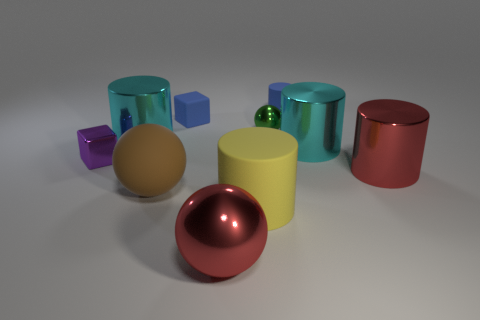Subtract all tiny spheres. How many spheres are left? 2 Subtract all brown spheres. How many spheres are left? 2 Subtract all blocks. How many objects are left? 8 Subtract 2 cylinders. How many cylinders are left? 3 Subtract all red balls. How many blue blocks are left? 1 Add 3 yellow matte objects. How many yellow matte objects exist? 4 Subtract 1 blue blocks. How many objects are left? 9 Subtract all gray blocks. Subtract all purple cylinders. How many blocks are left? 2 Subtract all tiny blue cylinders. Subtract all tiny blue objects. How many objects are left? 7 Add 6 red objects. How many red objects are left? 8 